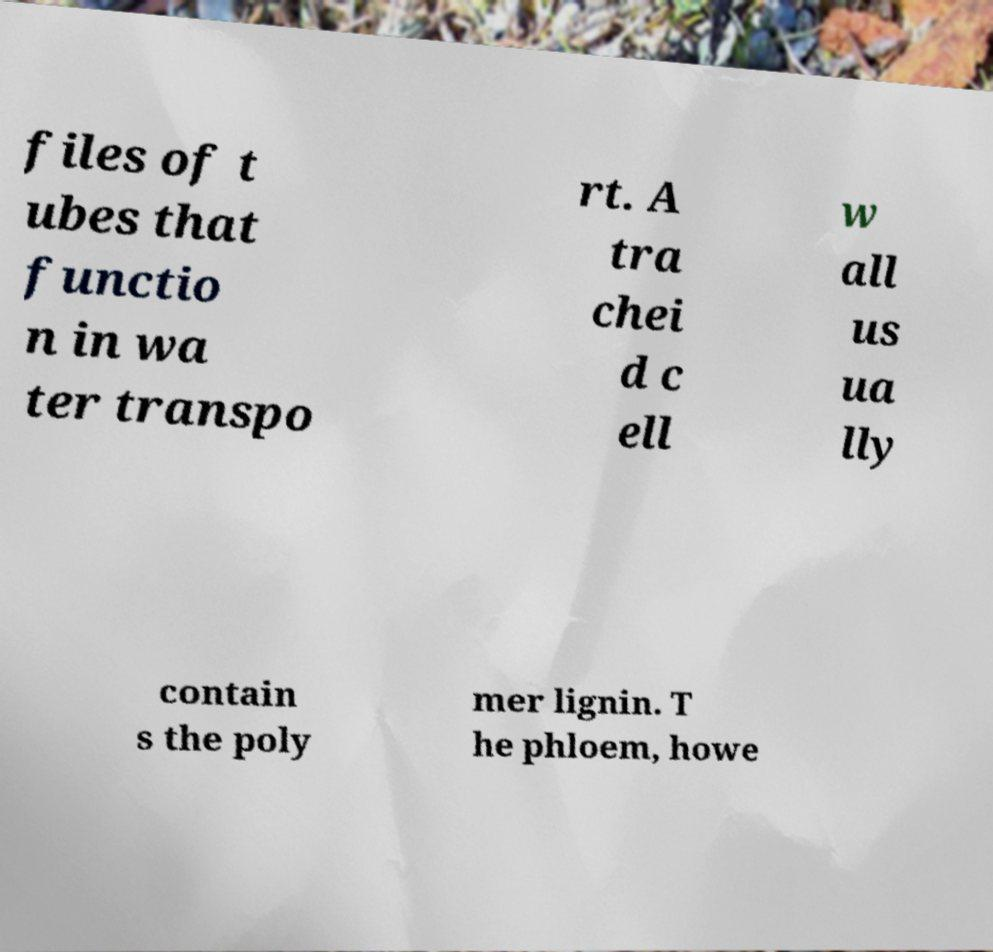Can you read and provide the text displayed in the image?This photo seems to have some interesting text. Can you extract and type it out for me? files of t ubes that functio n in wa ter transpo rt. A tra chei d c ell w all us ua lly contain s the poly mer lignin. T he phloem, howe 